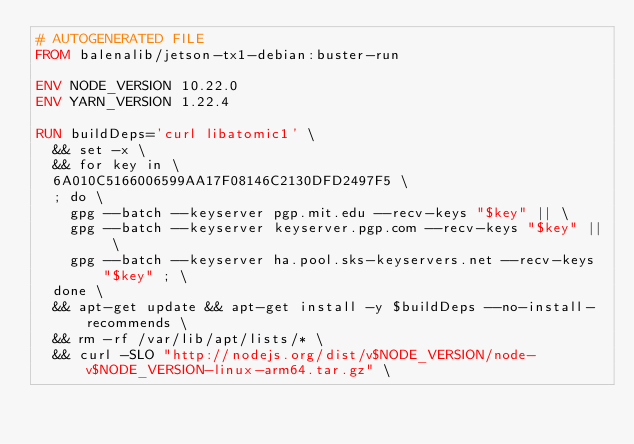Convert code to text. <code><loc_0><loc_0><loc_500><loc_500><_Dockerfile_># AUTOGENERATED FILE
FROM balenalib/jetson-tx1-debian:buster-run

ENV NODE_VERSION 10.22.0
ENV YARN_VERSION 1.22.4

RUN buildDeps='curl libatomic1' \
	&& set -x \
	&& for key in \
	6A010C5166006599AA17F08146C2130DFD2497F5 \
	; do \
		gpg --batch --keyserver pgp.mit.edu --recv-keys "$key" || \
		gpg --batch --keyserver keyserver.pgp.com --recv-keys "$key" || \
		gpg --batch --keyserver ha.pool.sks-keyservers.net --recv-keys "$key" ; \
	done \
	&& apt-get update && apt-get install -y $buildDeps --no-install-recommends \
	&& rm -rf /var/lib/apt/lists/* \
	&& curl -SLO "http://nodejs.org/dist/v$NODE_VERSION/node-v$NODE_VERSION-linux-arm64.tar.gz" \</code> 